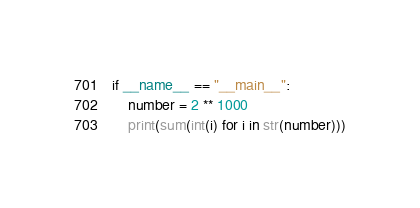<code> <loc_0><loc_0><loc_500><loc_500><_Python_>if __name__ == "__main__":
    number = 2 ** 1000
    print(sum(int(i) for i in str(number)))
</code> 